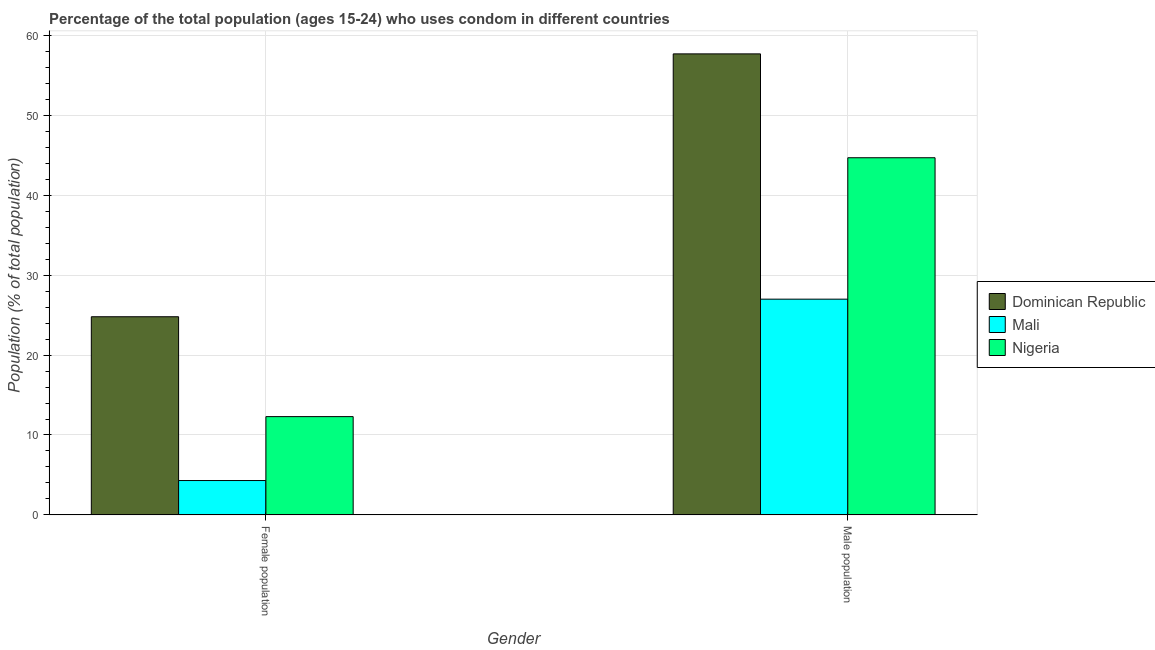Are the number of bars on each tick of the X-axis equal?
Offer a terse response. Yes. What is the label of the 2nd group of bars from the left?
Offer a very short reply. Male population. What is the female population in Dominican Republic?
Your response must be concise. 24.8. Across all countries, what is the maximum male population?
Your response must be concise. 57.7. In which country was the male population maximum?
Make the answer very short. Dominican Republic. In which country was the female population minimum?
Your answer should be compact. Mali. What is the total male population in the graph?
Provide a short and direct response. 129.4. What is the difference between the male population in Nigeria and that in Dominican Republic?
Give a very brief answer. -13. What is the difference between the female population in Mali and the male population in Dominican Republic?
Give a very brief answer. -53.4. What is the average male population per country?
Give a very brief answer. 43.13. What is the difference between the male population and female population in Dominican Republic?
Provide a succinct answer. 32.9. In how many countries, is the female population greater than 42 %?
Ensure brevity in your answer.  0. What is the ratio of the female population in Nigeria to that in Dominican Republic?
Ensure brevity in your answer.  0.5. What does the 2nd bar from the left in Female population represents?
Your response must be concise. Mali. What does the 3rd bar from the right in Female population represents?
Make the answer very short. Dominican Republic. Are all the bars in the graph horizontal?
Ensure brevity in your answer.  No. What is the difference between two consecutive major ticks on the Y-axis?
Ensure brevity in your answer.  10. Does the graph contain any zero values?
Offer a terse response. No. Does the graph contain grids?
Provide a succinct answer. Yes. What is the title of the graph?
Your response must be concise. Percentage of the total population (ages 15-24) who uses condom in different countries. What is the label or title of the X-axis?
Your answer should be compact. Gender. What is the label or title of the Y-axis?
Offer a very short reply. Population (% of total population) . What is the Population (% of total population)  of Dominican Republic in Female population?
Make the answer very short. 24.8. What is the Population (% of total population)  in Nigeria in Female population?
Your answer should be compact. 12.3. What is the Population (% of total population)  of Dominican Republic in Male population?
Offer a very short reply. 57.7. What is the Population (% of total population)  in Mali in Male population?
Offer a terse response. 27. What is the Population (% of total population)  in Nigeria in Male population?
Ensure brevity in your answer.  44.7. Across all Gender, what is the maximum Population (% of total population)  in Dominican Republic?
Offer a very short reply. 57.7. Across all Gender, what is the maximum Population (% of total population)  of Mali?
Make the answer very short. 27. Across all Gender, what is the maximum Population (% of total population)  of Nigeria?
Provide a succinct answer. 44.7. Across all Gender, what is the minimum Population (% of total population)  in Dominican Republic?
Make the answer very short. 24.8. Across all Gender, what is the minimum Population (% of total population)  of Nigeria?
Make the answer very short. 12.3. What is the total Population (% of total population)  in Dominican Republic in the graph?
Ensure brevity in your answer.  82.5. What is the total Population (% of total population)  in Mali in the graph?
Offer a terse response. 31.3. What is the difference between the Population (% of total population)  of Dominican Republic in Female population and that in Male population?
Your response must be concise. -32.9. What is the difference between the Population (% of total population)  of Mali in Female population and that in Male population?
Offer a very short reply. -22.7. What is the difference between the Population (% of total population)  in Nigeria in Female population and that in Male population?
Offer a terse response. -32.4. What is the difference between the Population (% of total population)  in Dominican Republic in Female population and the Population (% of total population)  in Mali in Male population?
Your answer should be compact. -2.2. What is the difference between the Population (% of total population)  in Dominican Republic in Female population and the Population (% of total population)  in Nigeria in Male population?
Offer a very short reply. -19.9. What is the difference between the Population (% of total population)  in Mali in Female population and the Population (% of total population)  in Nigeria in Male population?
Make the answer very short. -40.4. What is the average Population (% of total population)  in Dominican Republic per Gender?
Your answer should be compact. 41.25. What is the average Population (% of total population)  in Mali per Gender?
Offer a very short reply. 15.65. What is the difference between the Population (% of total population)  in Dominican Republic and Population (% of total population)  in Mali in Female population?
Keep it short and to the point. 20.5. What is the difference between the Population (% of total population)  in Mali and Population (% of total population)  in Nigeria in Female population?
Provide a short and direct response. -8. What is the difference between the Population (% of total population)  in Dominican Republic and Population (% of total population)  in Mali in Male population?
Give a very brief answer. 30.7. What is the difference between the Population (% of total population)  in Dominican Republic and Population (% of total population)  in Nigeria in Male population?
Your answer should be very brief. 13. What is the difference between the Population (% of total population)  in Mali and Population (% of total population)  in Nigeria in Male population?
Give a very brief answer. -17.7. What is the ratio of the Population (% of total population)  of Dominican Republic in Female population to that in Male population?
Your answer should be very brief. 0.43. What is the ratio of the Population (% of total population)  of Mali in Female population to that in Male population?
Make the answer very short. 0.16. What is the ratio of the Population (% of total population)  of Nigeria in Female population to that in Male population?
Provide a succinct answer. 0.28. What is the difference between the highest and the second highest Population (% of total population)  in Dominican Republic?
Keep it short and to the point. 32.9. What is the difference between the highest and the second highest Population (% of total population)  in Mali?
Your response must be concise. 22.7. What is the difference between the highest and the second highest Population (% of total population)  in Nigeria?
Ensure brevity in your answer.  32.4. What is the difference between the highest and the lowest Population (% of total population)  in Dominican Republic?
Offer a terse response. 32.9. What is the difference between the highest and the lowest Population (% of total population)  of Mali?
Keep it short and to the point. 22.7. What is the difference between the highest and the lowest Population (% of total population)  of Nigeria?
Offer a terse response. 32.4. 